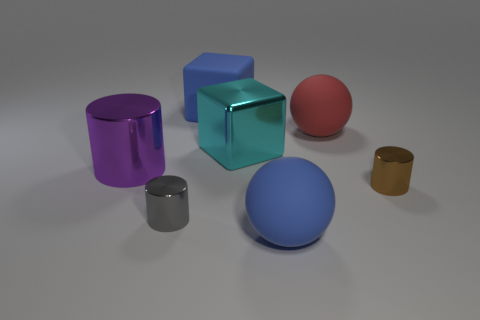Subtract all small brown cylinders. How many cylinders are left? 2 Subtract all purple cylinders. How many cylinders are left? 2 Add 1 brown objects. How many objects exist? 8 Subtract all blocks. How many objects are left? 5 Subtract 2 cubes. How many cubes are left? 0 Add 3 small cylinders. How many small cylinders exist? 5 Subtract 1 cyan blocks. How many objects are left? 6 Subtract all brown cubes. Subtract all green cylinders. How many cubes are left? 2 Subtract all green balls. How many blue cubes are left? 1 Subtract all red matte spheres. Subtract all large cylinders. How many objects are left? 5 